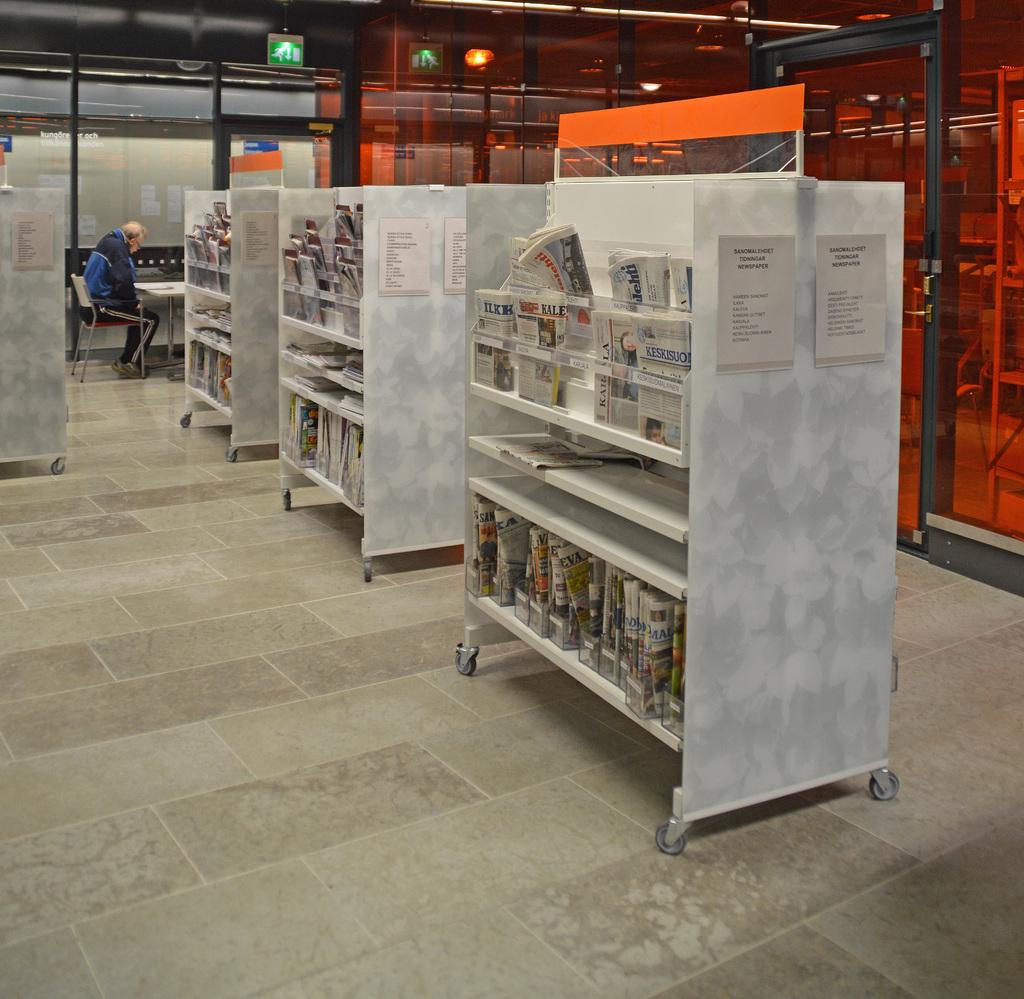<image>
Render a clear and concise summary of the photo. A shelving unit has the word newspaper on a piece of paper posted on it. 